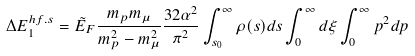<formula> <loc_0><loc_0><loc_500><loc_500>\Delta E _ { 1 } ^ { h f . s } = \tilde { E } _ { F } \frac { m _ { p } m _ { \mu } } { m _ { p } ^ { 2 } - m _ { \mu } ^ { 2 } } \frac { 3 2 \alpha ^ { 2 } } { \pi ^ { 2 } } \int _ { s _ { 0 } } ^ { \infty } \rho ( s ) d s \int _ { 0 } ^ { \infty } d \xi \int _ { 0 } ^ { \infty } p ^ { 2 } d p</formula> 